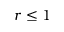Convert formula to latex. <formula><loc_0><loc_0><loc_500><loc_500>r \leq 1</formula> 